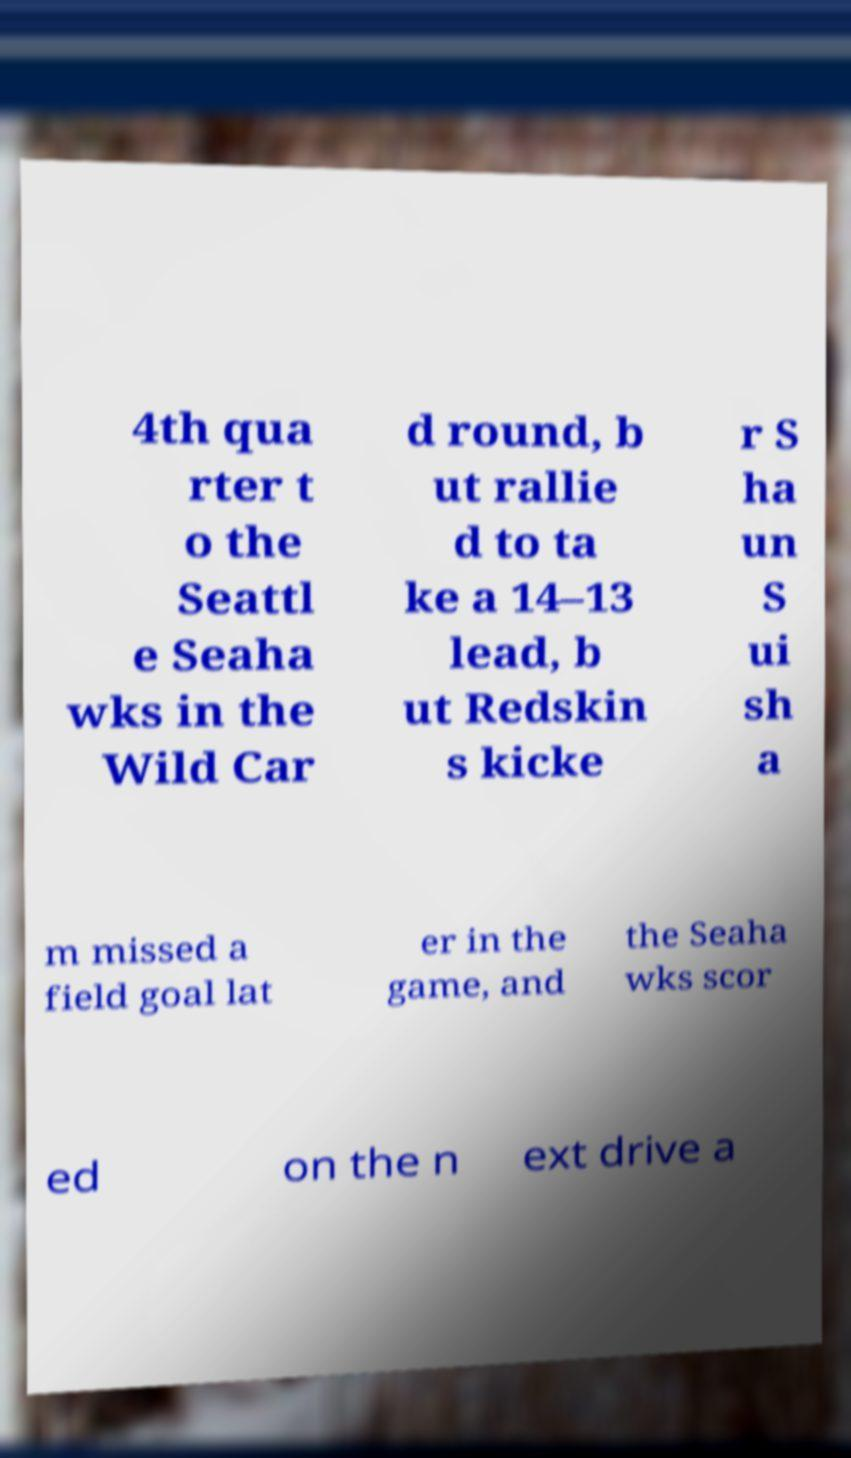I need the written content from this picture converted into text. Can you do that? 4th qua rter t o the Seattl e Seaha wks in the Wild Car d round, b ut rallie d to ta ke a 14–13 lead, b ut Redskin s kicke r S ha un S ui sh a m missed a field goal lat er in the game, and the Seaha wks scor ed on the n ext drive a 